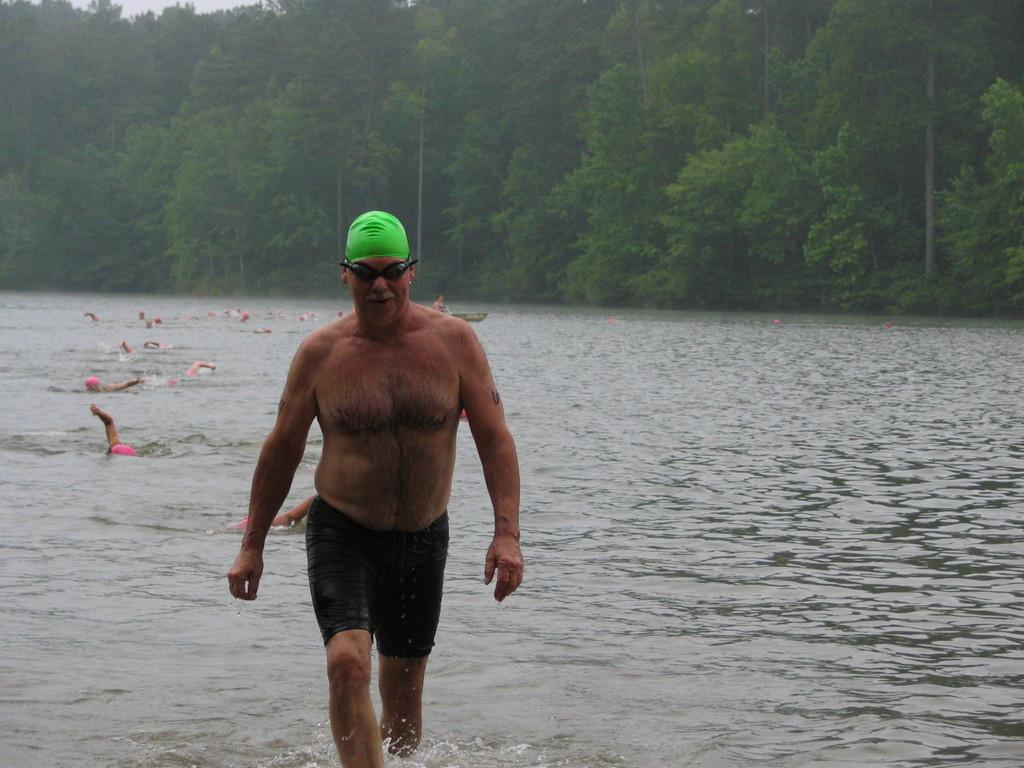What is the main subject in the center of the image? There is a person in the center of the image. What is the person doing in the image? The person is walking. What accessories is the person wearing in the image? The person is wearing glasses and a cap. What can be seen in the background of the image? There are trees and people swimming in the water in the background of the image. How many cows are tied up in a knot in the image? There are no cows or knots present in the image. 